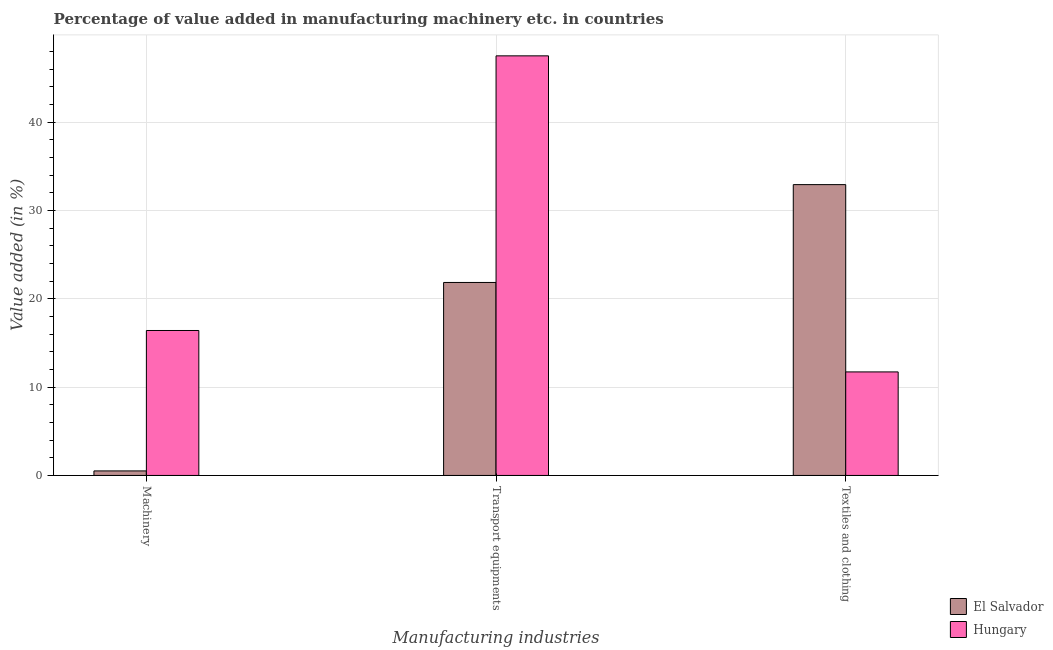How many groups of bars are there?
Offer a very short reply. 3. Are the number of bars per tick equal to the number of legend labels?
Your answer should be compact. Yes. Are the number of bars on each tick of the X-axis equal?
Your answer should be compact. Yes. How many bars are there on the 1st tick from the left?
Your answer should be compact. 2. How many bars are there on the 3rd tick from the right?
Make the answer very short. 2. What is the label of the 2nd group of bars from the left?
Ensure brevity in your answer.  Transport equipments. What is the value added in manufacturing transport equipments in Hungary?
Your answer should be compact. 47.49. Across all countries, what is the maximum value added in manufacturing machinery?
Make the answer very short. 16.41. Across all countries, what is the minimum value added in manufacturing textile and clothing?
Provide a short and direct response. 11.72. In which country was the value added in manufacturing transport equipments maximum?
Offer a very short reply. Hungary. In which country was the value added in manufacturing machinery minimum?
Your answer should be compact. El Salvador. What is the total value added in manufacturing textile and clothing in the graph?
Offer a very short reply. 44.63. What is the difference between the value added in manufacturing machinery in El Salvador and that in Hungary?
Make the answer very short. -15.89. What is the difference between the value added in manufacturing machinery in El Salvador and the value added in manufacturing transport equipments in Hungary?
Offer a very short reply. -46.98. What is the average value added in manufacturing transport equipments per country?
Provide a short and direct response. 34.67. What is the difference between the value added in manufacturing machinery and value added in manufacturing textile and clothing in El Salvador?
Keep it short and to the point. -32.4. In how many countries, is the value added in manufacturing machinery greater than 8 %?
Your response must be concise. 1. What is the ratio of the value added in manufacturing transport equipments in El Salvador to that in Hungary?
Ensure brevity in your answer.  0.46. Is the value added in manufacturing textile and clothing in Hungary less than that in El Salvador?
Offer a very short reply. Yes. Is the difference between the value added in manufacturing transport equipments in El Salvador and Hungary greater than the difference between the value added in manufacturing machinery in El Salvador and Hungary?
Make the answer very short. No. What is the difference between the highest and the second highest value added in manufacturing transport equipments?
Offer a terse response. 25.65. What is the difference between the highest and the lowest value added in manufacturing machinery?
Provide a short and direct response. 15.89. In how many countries, is the value added in manufacturing transport equipments greater than the average value added in manufacturing transport equipments taken over all countries?
Keep it short and to the point. 1. What does the 2nd bar from the left in Transport equipments represents?
Give a very brief answer. Hungary. What does the 1st bar from the right in Machinery represents?
Give a very brief answer. Hungary. Is it the case that in every country, the sum of the value added in manufacturing machinery and value added in manufacturing transport equipments is greater than the value added in manufacturing textile and clothing?
Offer a very short reply. No. How many bars are there?
Make the answer very short. 6. Are all the bars in the graph horizontal?
Your answer should be compact. No. Are the values on the major ticks of Y-axis written in scientific E-notation?
Keep it short and to the point. No. Does the graph contain grids?
Offer a very short reply. Yes. Where does the legend appear in the graph?
Your response must be concise. Bottom right. How are the legend labels stacked?
Give a very brief answer. Vertical. What is the title of the graph?
Your answer should be compact. Percentage of value added in manufacturing machinery etc. in countries. What is the label or title of the X-axis?
Offer a very short reply. Manufacturing industries. What is the label or title of the Y-axis?
Provide a short and direct response. Value added (in %). What is the Value added (in %) in El Salvador in Machinery?
Your response must be concise. 0.51. What is the Value added (in %) of Hungary in Machinery?
Offer a very short reply. 16.41. What is the Value added (in %) of El Salvador in Transport equipments?
Offer a terse response. 21.84. What is the Value added (in %) in Hungary in Transport equipments?
Offer a terse response. 47.49. What is the Value added (in %) in El Salvador in Textiles and clothing?
Provide a succinct answer. 32.92. What is the Value added (in %) of Hungary in Textiles and clothing?
Provide a short and direct response. 11.72. Across all Manufacturing industries, what is the maximum Value added (in %) of El Salvador?
Your answer should be very brief. 32.92. Across all Manufacturing industries, what is the maximum Value added (in %) in Hungary?
Your answer should be very brief. 47.49. Across all Manufacturing industries, what is the minimum Value added (in %) in El Salvador?
Ensure brevity in your answer.  0.51. Across all Manufacturing industries, what is the minimum Value added (in %) of Hungary?
Offer a very short reply. 11.72. What is the total Value added (in %) in El Salvador in the graph?
Provide a succinct answer. 55.27. What is the total Value added (in %) in Hungary in the graph?
Your answer should be compact. 75.61. What is the difference between the Value added (in %) of El Salvador in Machinery and that in Transport equipments?
Your answer should be very brief. -21.33. What is the difference between the Value added (in %) in Hungary in Machinery and that in Transport equipments?
Keep it short and to the point. -31.08. What is the difference between the Value added (in %) of El Salvador in Machinery and that in Textiles and clothing?
Provide a short and direct response. -32.4. What is the difference between the Value added (in %) in Hungary in Machinery and that in Textiles and clothing?
Ensure brevity in your answer.  4.69. What is the difference between the Value added (in %) of El Salvador in Transport equipments and that in Textiles and clothing?
Keep it short and to the point. -11.07. What is the difference between the Value added (in %) of Hungary in Transport equipments and that in Textiles and clothing?
Your answer should be compact. 35.77. What is the difference between the Value added (in %) in El Salvador in Machinery and the Value added (in %) in Hungary in Transport equipments?
Offer a terse response. -46.98. What is the difference between the Value added (in %) of El Salvador in Machinery and the Value added (in %) of Hungary in Textiles and clothing?
Provide a succinct answer. -11.2. What is the difference between the Value added (in %) of El Salvador in Transport equipments and the Value added (in %) of Hungary in Textiles and clothing?
Ensure brevity in your answer.  10.12. What is the average Value added (in %) of El Salvador per Manufacturing industries?
Make the answer very short. 18.42. What is the average Value added (in %) in Hungary per Manufacturing industries?
Ensure brevity in your answer.  25.2. What is the difference between the Value added (in %) of El Salvador and Value added (in %) of Hungary in Machinery?
Offer a very short reply. -15.89. What is the difference between the Value added (in %) in El Salvador and Value added (in %) in Hungary in Transport equipments?
Make the answer very short. -25.65. What is the difference between the Value added (in %) of El Salvador and Value added (in %) of Hungary in Textiles and clothing?
Make the answer very short. 21.2. What is the ratio of the Value added (in %) of El Salvador in Machinery to that in Transport equipments?
Offer a very short reply. 0.02. What is the ratio of the Value added (in %) of Hungary in Machinery to that in Transport equipments?
Your answer should be compact. 0.35. What is the ratio of the Value added (in %) of El Salvador in Machinery to that in Textiles and clothing?
Ensure brevity in your answer.  0.02. What is the ratio of the Value added (in %) in Hungary in Machinery to that in Textiles and clothing?
Make the answer very short. 1.4. What is the ratio of the Value added (in %) of El Salvador in Transport equipments to that in Textiles and clothing?
Your answer should be very brief. 0.66. What is the ratio of the Value added (in %) in Hungary in Transport equipments to that in Textiles and clothing?
Your answer should be compact. 4.05. What is the difference between the highest and the second highest Value added (in %) in El Salvador?
Provide a succinct answer. 11.07. What is the difference between the highest and the second highest Value added (in %) of Hungary?
Make the answer very short. 31.08. What is the difference between the highest and the lowest Value added (in %) in El Salvador?
Give a very brief answer. 32.4. What is the difference between the highest and the lowest Value added (in %) in Hungary?
Offer a very short reply. 35.77. 